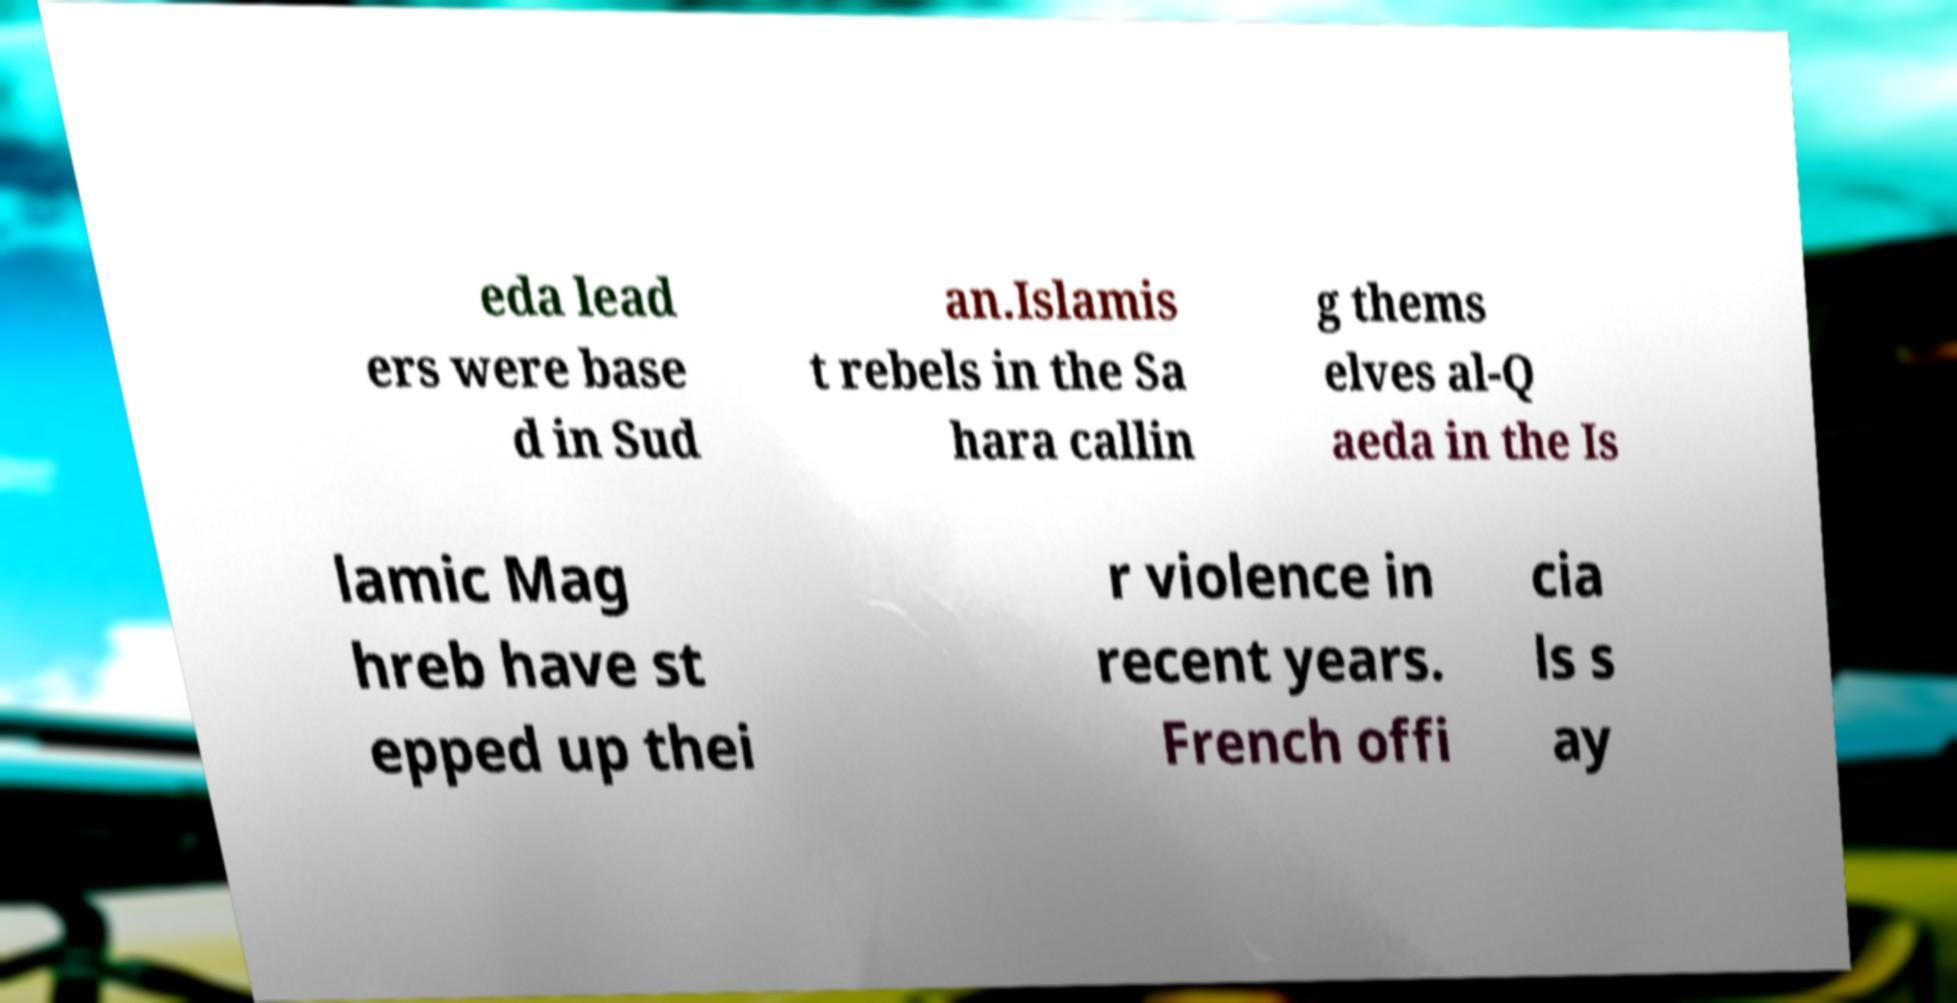Can you accurately transcribe the text from the provided image for me? eda lead ers were base d in Sud an.Islamis t rebels in the Sa hara callin g thems elves al-Q aeda in the Is lamic Mag hreb have st epped up thei r violence in recent years. French offi cia ls s ay 